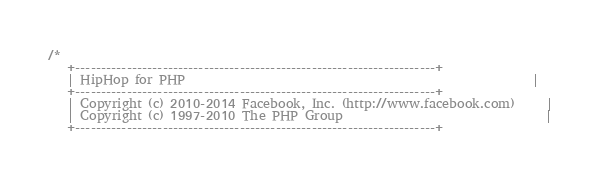Convert code to text. <code><loc_0><loc_0><loc_500><loc_500><_C++_>/*
   +----------------------------------------------------------------------+
   | HipHop for PHP                                                       |
   +----------------------------------------------------------------------+
   | Copyright (c) 2010-2014 Facebook, Inc. (http://www.facebook.com)     |
   | Copyright (c) 1997-2010 The PHP Group                                |
   +----------------------------------------------------------------------+</code> 